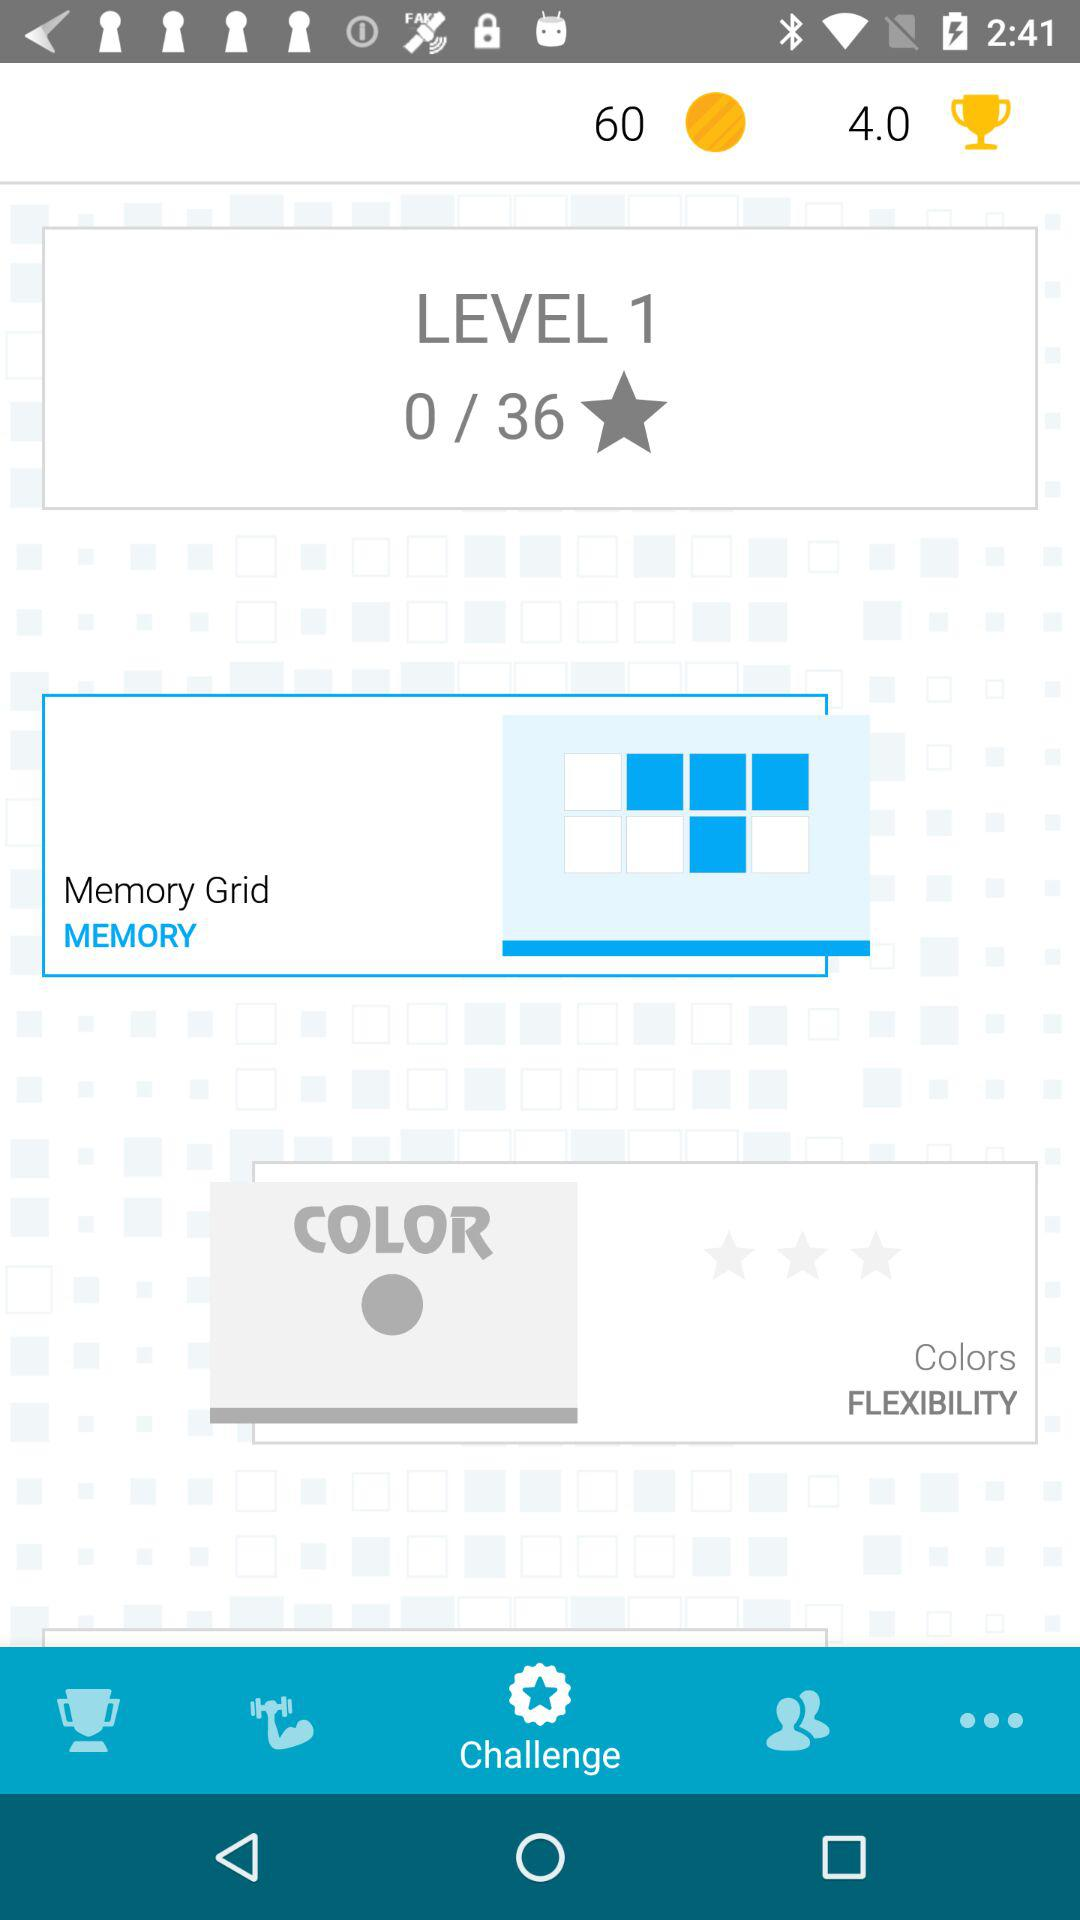Which tab is selected? The selected tab is "Challenge". 